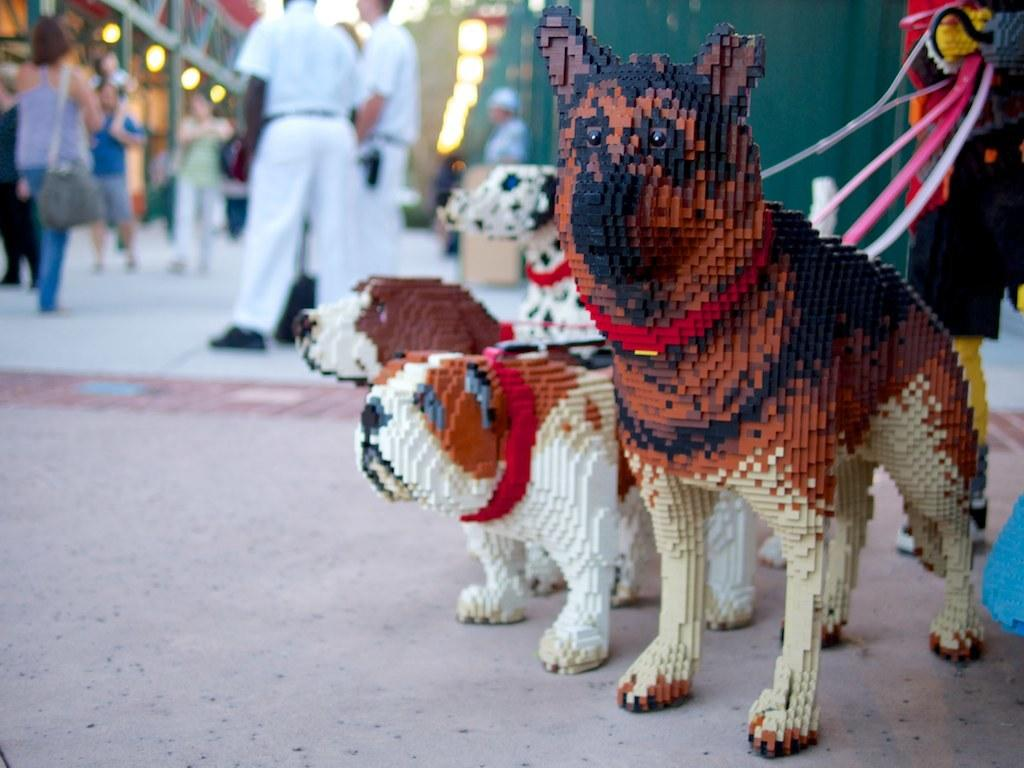What type of toys are on the ground in the image? There are toy dogs on the ground. What can be seen in the background of the image? There are people and lights present in the background of the image. How would you describe the overall quality of the image? The image is blurry. How does the neck of the toy dog look like in the image? There is no specific detail about the toy dog's neck visible in the image, as it is blurry and the focus is on the toy dogs as a whole. 